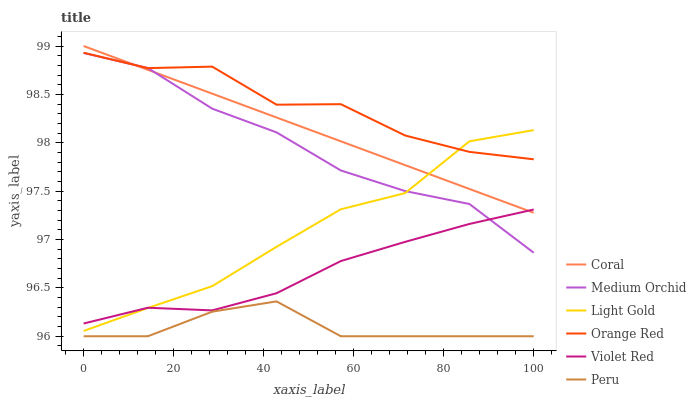Does Peru have the minimum area under the curve?
Answer yes or no. Yes. Does Orange Red have the maximum area under the curve?
Answer yes or no. Yes. Does Coral have the minimum area under the curve?
Answer yes or no. No. Does Coral have the maximum area under the curve?
Answer yes or no. No. Is Coral the smoothest?
Answer yes or no. Yes. Is Orange Red the roughest?
Answer yes or no. Yes. Is Medium Orchid the smoothest?
Answer yes or no. No. Is Medium Orchid the roughest?
Answer yes or no. No. Does Peru have the lowest value?
Answer yes or no. Yes. Does Coral have the lowest value?
Answer yes or no. No. Does Coral have the highest value?
Answer yes or no. Yes. Does Medium Orchid have the highest value?
Answer yes or no. No. Is Peru less than Violet Red?
Answer yes or no. Yes. Is Medium Orchid greater than Peru?
Answer yes or no. Yes. Does Medium Orchid intersect Violet Red?
Answer yes or no. Yes. Is Medium Orchid less than Violet Red?
Answer yes or no. No. Is Medium Orchid greater than Violet Red?
Answer yes or no. No. Does Peru intersect Violet Red?
Answer yes or no. No. 